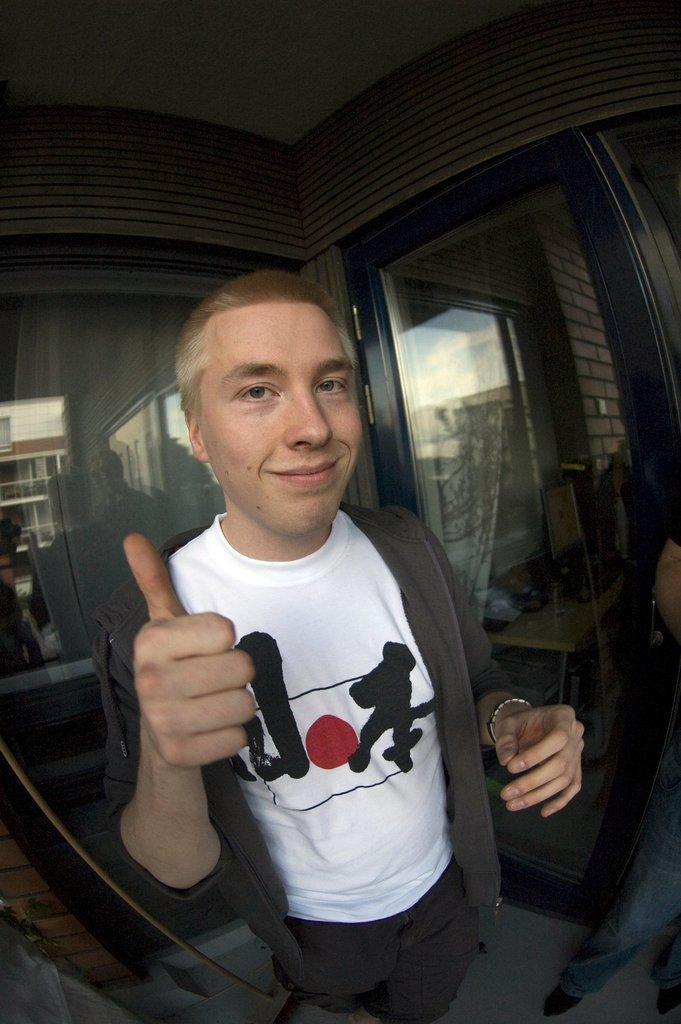Who or what can be seen in the image? There are people in the image. What is visible behind the people? There are glass doors in the background of the image, and a building can be seen through them. What else can be seen in the background of the image? There is a wall in the background of the image. What type of coach is parked near the building in the image? There is no coach visible in the image; only people, glass doors, a building, and a wall are present. What kind of sponge is being used by the people in the image? There is no sponge visible in the image, and it is not mentioned that the people are using any sponge. 